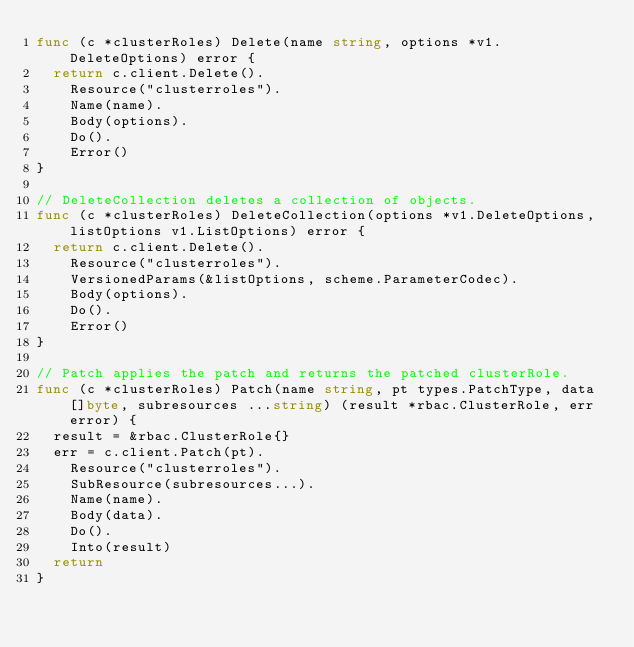<code> <loc_0><loc_0><loc_500><loc_500><_Go_>func (c *clusterRoles) Delete(name string, options *v1.DeleteOptions) error {
	return c.client.Delete().
		Resource("clusterroles").
		Name(name).
		Body(options).
		Do().
		Error()
}

// DeleteCollection deletes a collection of objects.
func (c *clusterRoles) DeleteCollection(options *v1.DeleteOptions, listOptions v1.ListOptions) error {
	return c.client.Delete().
		Resource("clusterroles").
		VersionedParams(&listOptions, scheme.ParameterCodec).
		Body(options).
		Do().
		Error()
}

// Patch applies the patch and returns the patched clusterRole.
func (c *clusterRoles) Patch(name string, pt types.PatchType, data []byte, subresources ...string) (result *rbac.ClusterRole, err error) {
	result = &rbac.ClusterRole{}
	err = c.client.Patch(pt).
		Resource("clusterroles").
		SubResource(subresources...).
		Name(name).
		Body(data).
		Do().
		Into(result)
	return
}
</code> 